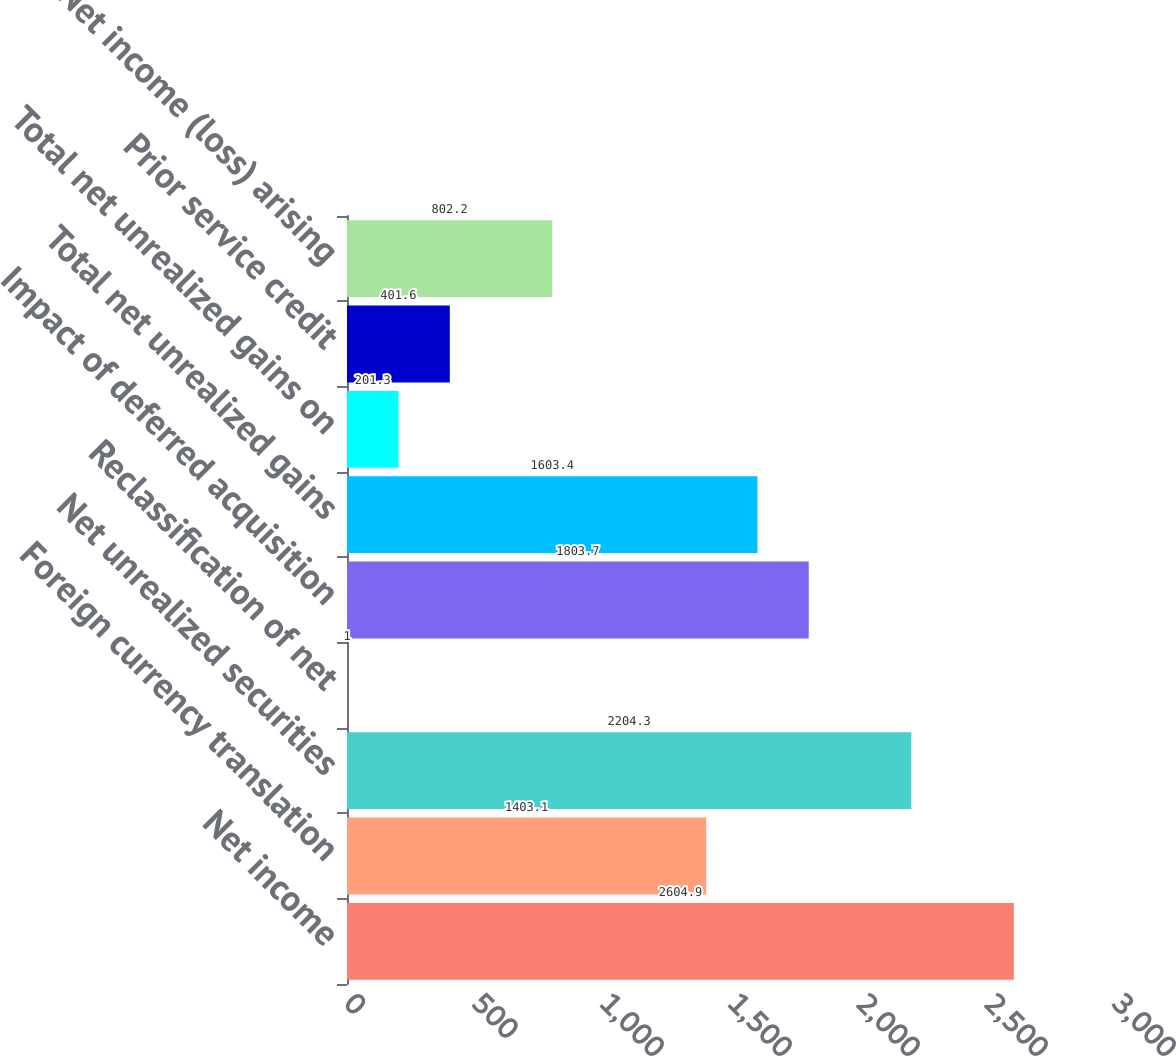<chart> <loc_0><loc_0><loc_500><loc_500><bar_chart><fcel>Net income<fcel>Foreign currency translation<fcel>Net unrealized securities<fcel>Reclassification of net<fcel>Impact of deferred acquisition<fcel>Total net unrealized gains<fcel>Total net unrealized gains on<fcel>Prior service credit<fcel>Net income (loss) arising<nl><fcel>2604.9<fcel>1403.1<fcel>2204.3<fcel>1<fcel>1803.7<fcel>1603.4<fcel>201.3<fcel>401.6<fcel>802.2<nl></chart> 